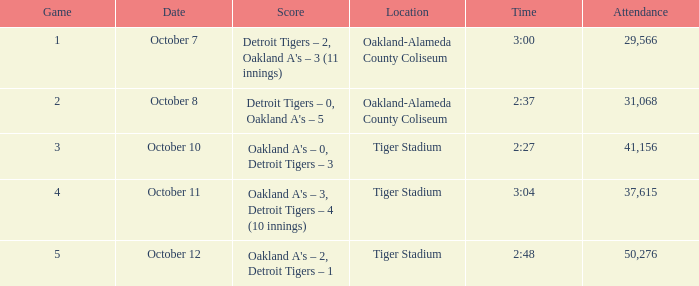What was the tally at tiger stadium on october 12? Oakland A's – 2, Detroit Tigers – 1. 